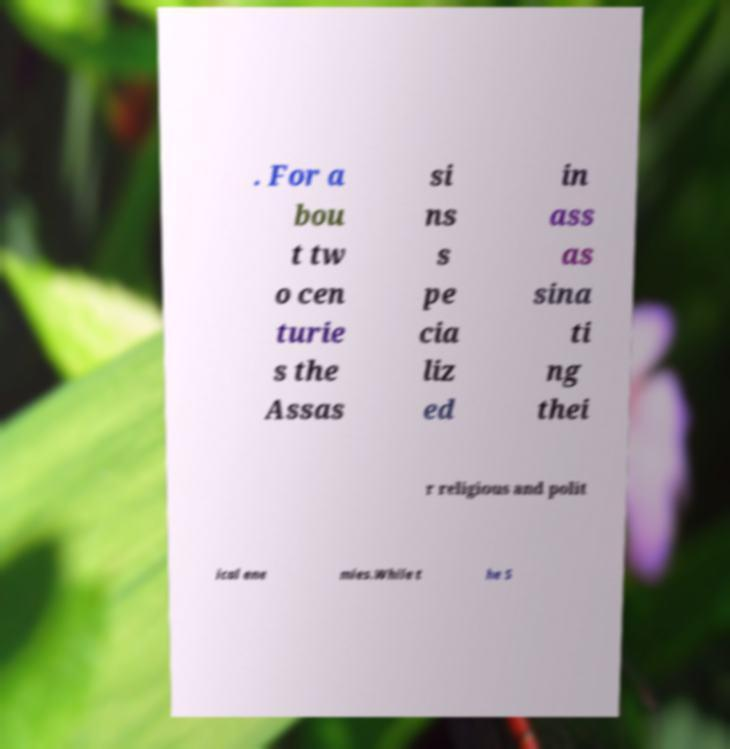I need the written content from this picture converted into text. Can you do that? . For a bou t tw o cen turie s the Assas si ns s pe cia liz ed in ass as sina ti ng thei r religious and polit ical ene mies.While t he S 